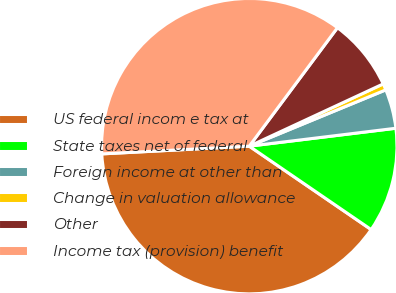Convert chart to OTSL. <chart><loc_0><loc_0><loc_500><loc_500><pie_chart><fcel>US federal incom e tax at<fcel>State taxes net of federal<fcel>Foreign income at other than<fcel>Change in valuation allowance<fcel>Other<fcel>Income tax (provision) benefit<nl><fcel>39.62%<fcel>11.49%<fcel>4.29%<fcel>0.7%<fcel>7.89%<fcel>36.02%<nl></chart> 